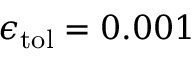<formula> <loc_0><loc_0><loc_500><loc_500>\epsilon _ { t o l } = 0 . 0 0 1</formula> 